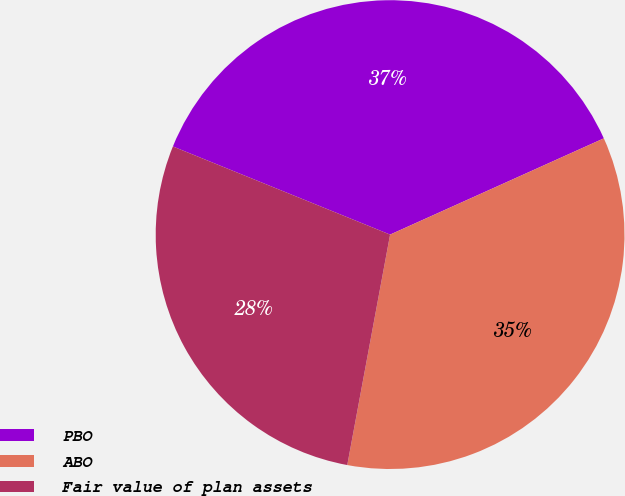Convert chart to OTSL. <chart><loc_0><loc_0><loc_500><loc_500><pie_chart><fcel>PBO<fcel>ABO<fcel>Fair value of plan assets<nl><fcel>37.13%<fcel>34.66%<fcel>28.21%<nl></chart> 